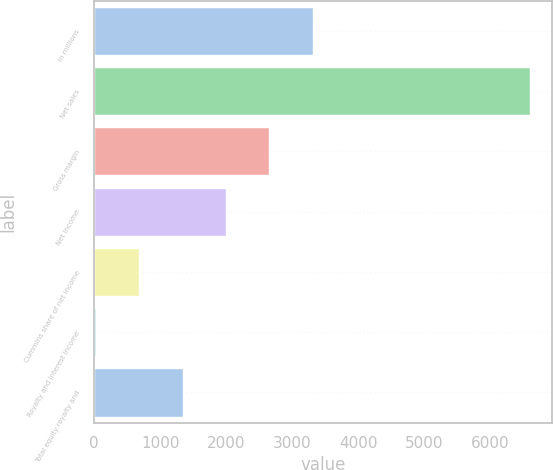Convert chart to OTSL. <chart><loc_0><loc_0><loc_500><loc_500><bar_chart><fcel>In millions<fcel>Net sales<fcel>Gross margin<fcel>Net income<fcel>Cummins share of net income<fcel>Royalty and interest income<fcel>Total equity royalty and<nl><fcel>3316<fcel>6610<fcel>2657.2<fcel>1998.4<fcel>680.8<fcel>22<fcel>1339.6<nl></chart> 